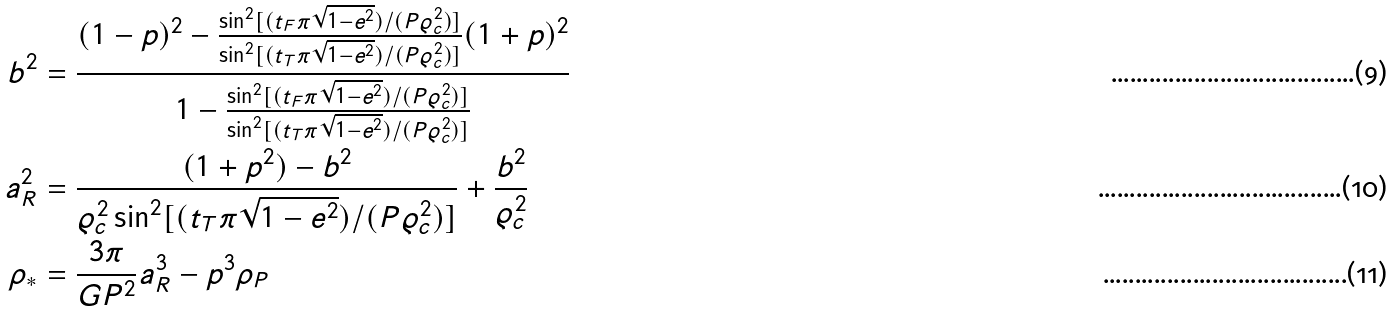<formula> <loc_0><loc_0><loc_500><loc_500>b ^ { 2 } & = \frac { ( 1 - p ) ^ { 2 } - \frac { \sin ^ { 2 } [ ( t _ { F } \pi \sqrt { 1 - e ^ { 2 } } ) / ( P \varrho _ { c } ^ { 2 } ) ] } { \sin ^ { 2 } [ ( t _ { T } \pi \sqrt { 1 - e ^ { 2 } } ) / ( P \varrho _ { c } ^ { 2 } ) ] } ( 1 + p ) ^ { 2 } } { 1 - \frac { \sin ^ { 2 } [ ( t _ { F } \pi \sqrt { 1 - e ^ { 2 } } ) / ( P \varrho _ { c } ^ { 2 } ) ] } { \sin ^ { 2 } [ ( t _ { T } \pi \sqrt { 1 - e ^ { 2 } } ) / ( P \varrho _ { c } ^ { 2 } ) ] } } \\ a _ { R } ^ { 2 } & = \frac { ( 1 + p ^ { 2 } ) - b ^ { 2 } } { \varrho _ { c } ^ { 2 } \sin ^ { 2 } [ ( t _ { T } \pi \sqrt { 1 - e ^ { 2 } } ) / ( P \varrho _ { c } ^ { 2 } ) ] } + \frac { b ^ { 2 } } { \varrho _ { c } ^ { 2 } } \\ \rho _ { * } & = \frac { 3 \pi } { G P ^ { 2 } } a _ { R } ^ { 3 } - p ^ { 3 } \rho _ { P }</formula> 